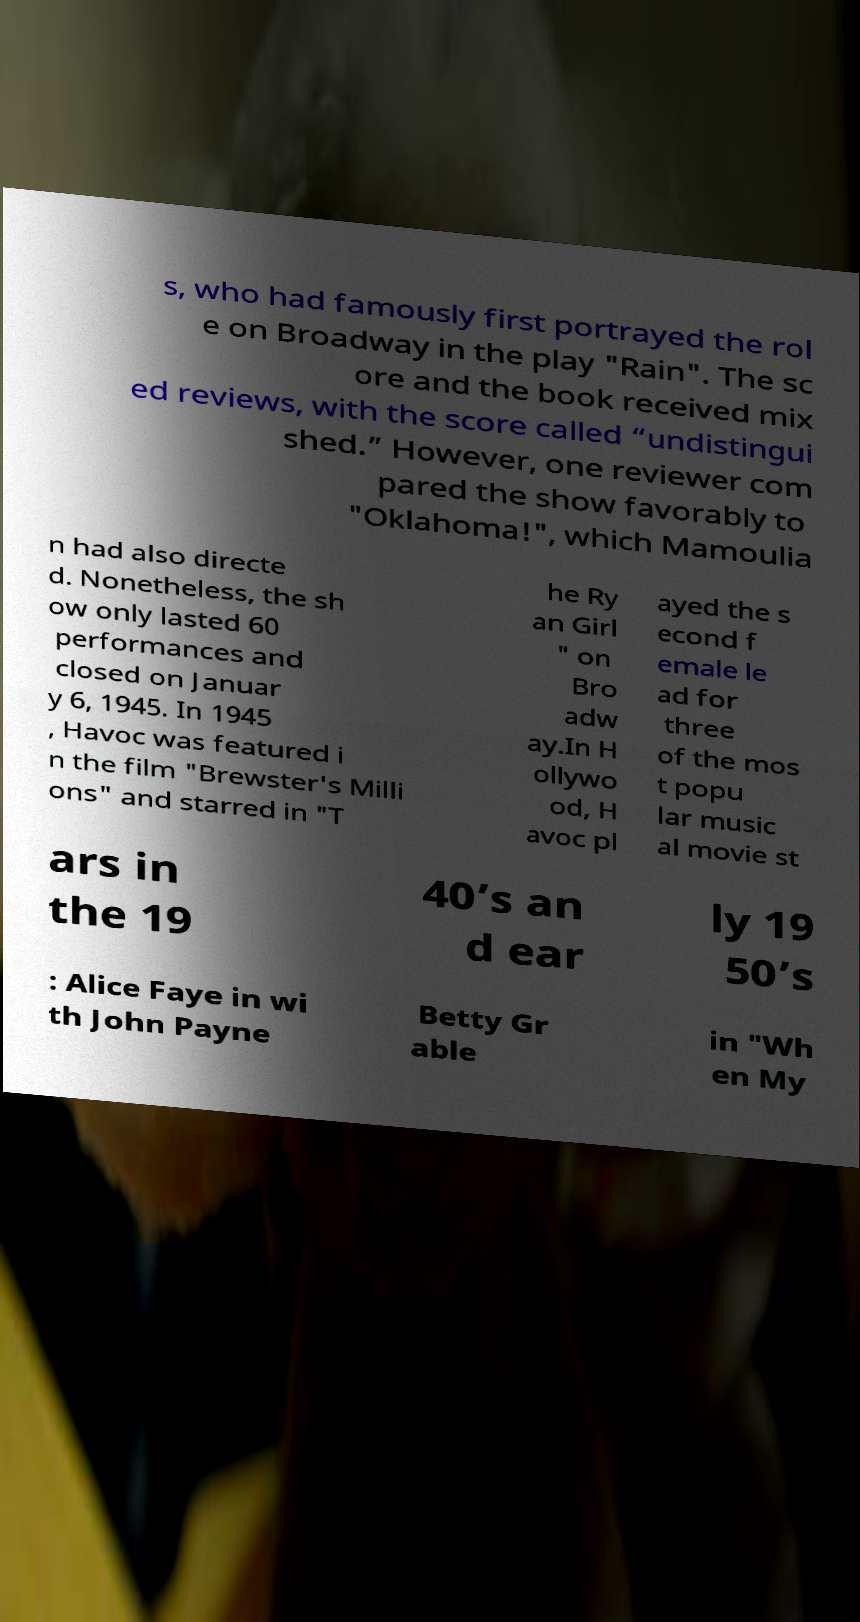Please identify and transcribe the text found in this image. s, who had famously first portrayed the rol e on Broadway in the play "Rain". The sc ore and the book received mix ed reviews, with the score called “undistingui shed.” However, one reviewer com pared the show favorably to "Oklahoma!", which Mamoulia n had also directe d. Nonetheless, the sh ow only lasted 60 performances and closed on Januar y 6, 1945. In 1945 , Havoc was featured i n the film "Brewster's Milli ons" and starred in "T he Ry an Girl " on Bro adw ay.In H ollywo od, H avoc pl ayed the s econd f emale le ad for three of the mos t popu lar music al movie st ars in the 19 40’s an d ear ly 19 50’s : Alice Faye in wi th John Payne Betty Gr able in "Wh en My 